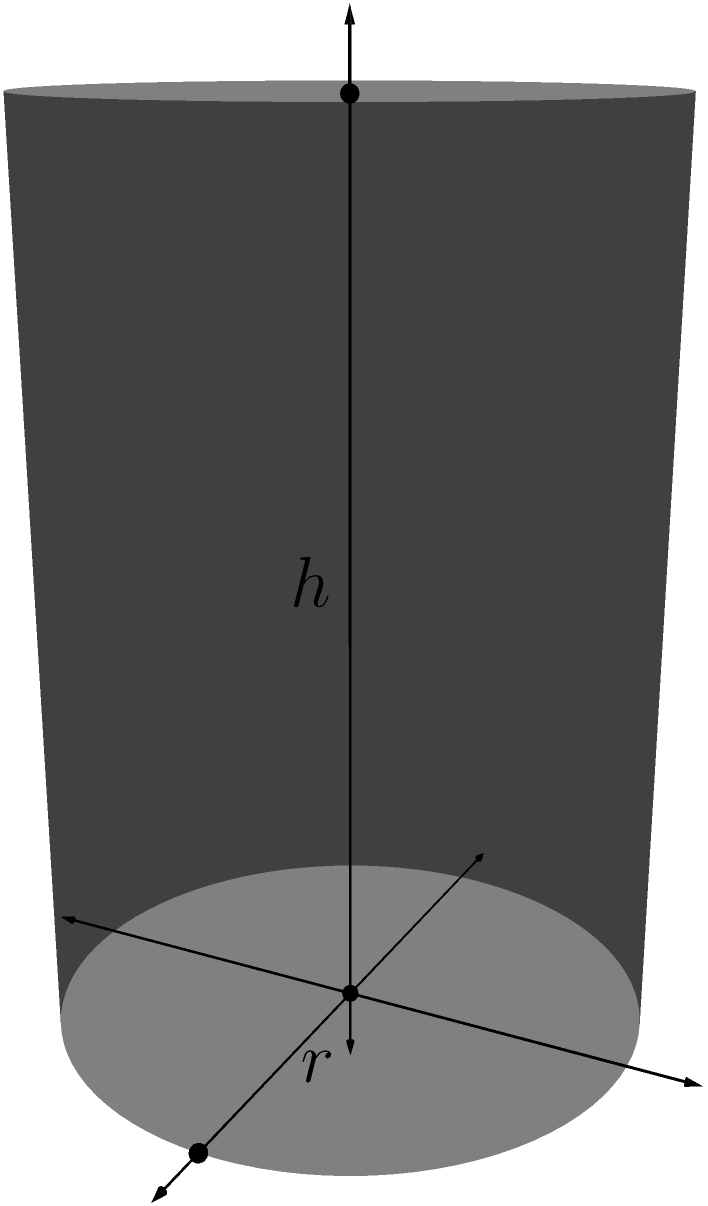You want to pack cylindrical miniature soldiers into a larger cylindrical container for storage. Each soldier has a radius of 0.5 cm and a height of 3 cm. The container has a radius of 10 cm and a height of 30 cm. What is the maximum number of soldiers that can be packed into the container, assuming optimal arrangement? Express your answer in terms of the floor function $\lfloor x \rfloor$. To solve this problem, we need to consider the most efficient packing arrangement for cylinders within a larger cylinder. The optimal arrangement is hexagonal packing in layers.

Step 1: Calculate the number of soldiers that can fit in a single layer.
- The area of the container's base: $A_c = \pi r_c^2 = \pi (10\text{ cm})^2 = 100\pi\text{ cm}^2$
- The area of a soldier's base: $A_s = \pi r_s^2 = \pi (0.5\text{ cm})^2 = 0.25\pi\text{ cm}^2$
- The efficiency of hexagonal packing: $\eta \approx 0.9069$
- Number of soldiers in a layer: $N_l = \lfloor \frac{A_c}{A_s} \cdot \eta \rfloor = \lfloor \frac{100\pi}{0.25\pi} \cdot 0.9069 \rfloor = \lfloor 362.76 \rfloor = 362$

Step 2: Calculate the number of layers that can fit in the container's height.
- Container height: 30 cm
- Soldier height: 3 cm
- Number of layers: $N_h = \lfloor \frac{30\text{ cm}}{3\text{ cm}} \rfloor = 10$

Step 3: Calculate the total number of soldiers.
- Total number = Number of soldiers per layer × Number of layers
- Total number = $362 \times 10 = 3620$

Therefore, the maximum number of soldiers that can be packed into the container is 3620.
Answer: $\lfloor 3620 \rfloor$ 